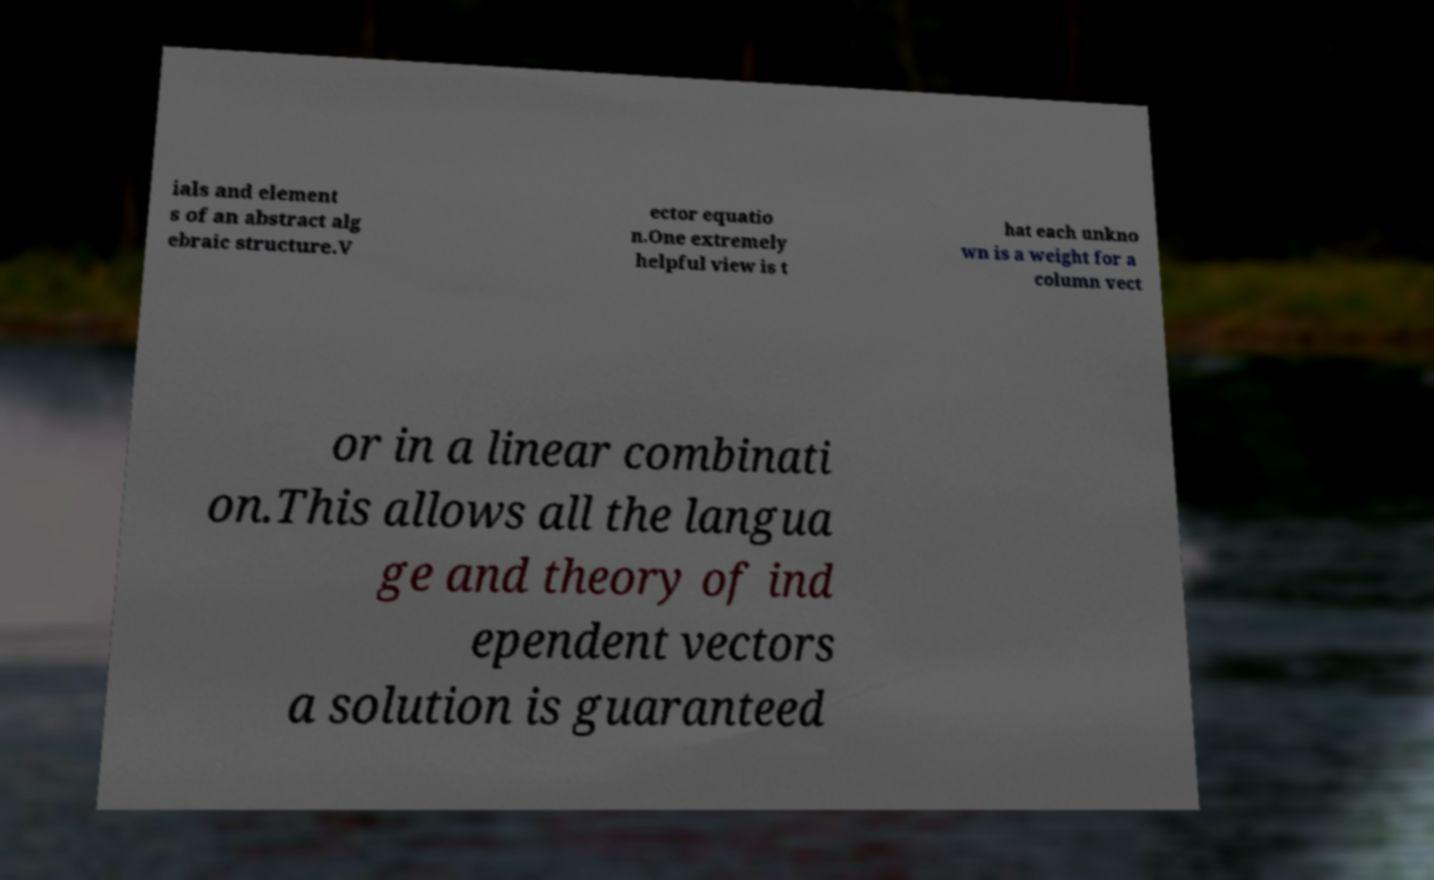Could you assist in decoding the text presented in this image and type it out clearly? ials and element s of an abstract alg ebraic structure.V ector equatio n.One extremely helpful view is t hat each unkno wn is a weight for a column vect or in a linear combinati on.This allows all the langua ge and theory of ind ependent vectors a solution is guaranteed 